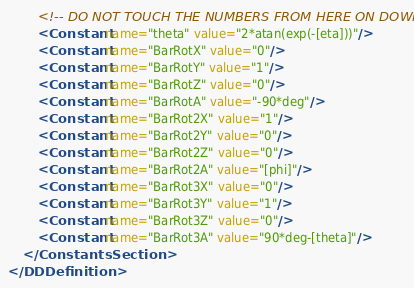<code> <loc_0><loc_0><loc_500><loc_500><_XML_>        <!-- DO NOT TOUCH THE NUMBERS FROM HERE ON DOWN -->
        <Constant name="theta" value="2*atan(exp(-[eta]))"/>
        <Constant name="BarRotX" value="0"/>
        <Constant name="BarRotY" value="1"/>
        <Constant name="BarRotZ" value="0"/>
        <Constant name="BarRotA" value="-90*deg"/>
        <Constant name="BarRot2X" value="1"/>
        <Constant name="BarRot2Y" value="0"/>
        <Constant name="BarRot2Z" value="0"/>
        <Constant name="BarRot2A" value="[phi]"/>
        <Constant name="BarRot3X" value="0"/>
        <Constant name="BarRot3Y" value="1"/>
        <Constant name="BarRot3Z" value="0"/>
        <Constant name="BarRot3A" value="90*deg-[theta]"/>
    </ConstantsSection>
</DDDefinition>
</code> 